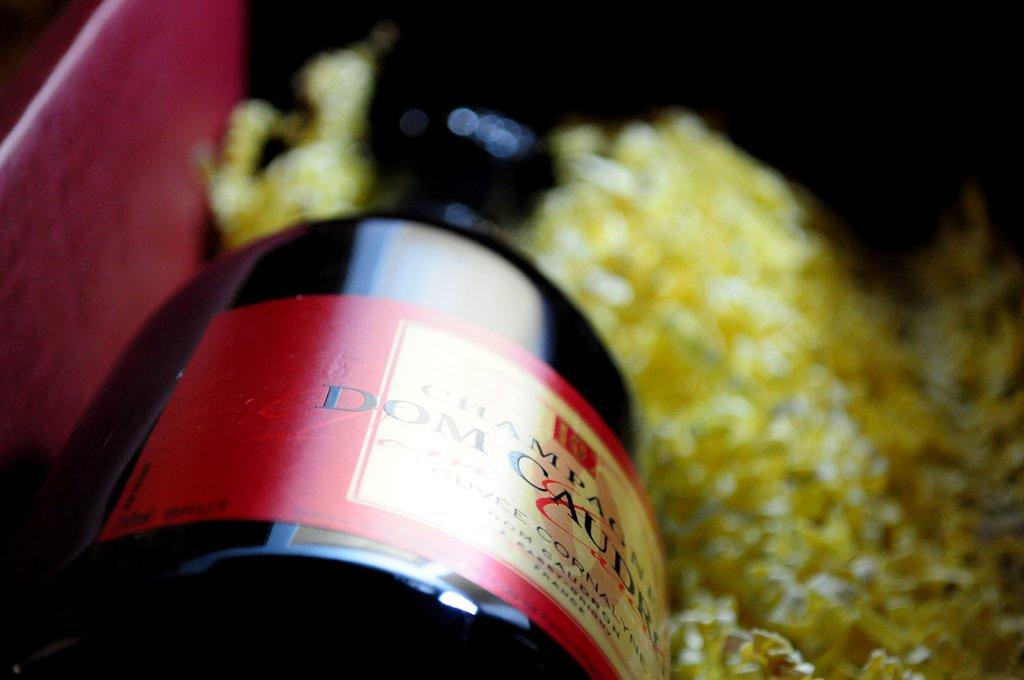<image>
Render a clear and concise summary of the photo. A bottle laying on its side says "DOM" on the label. 